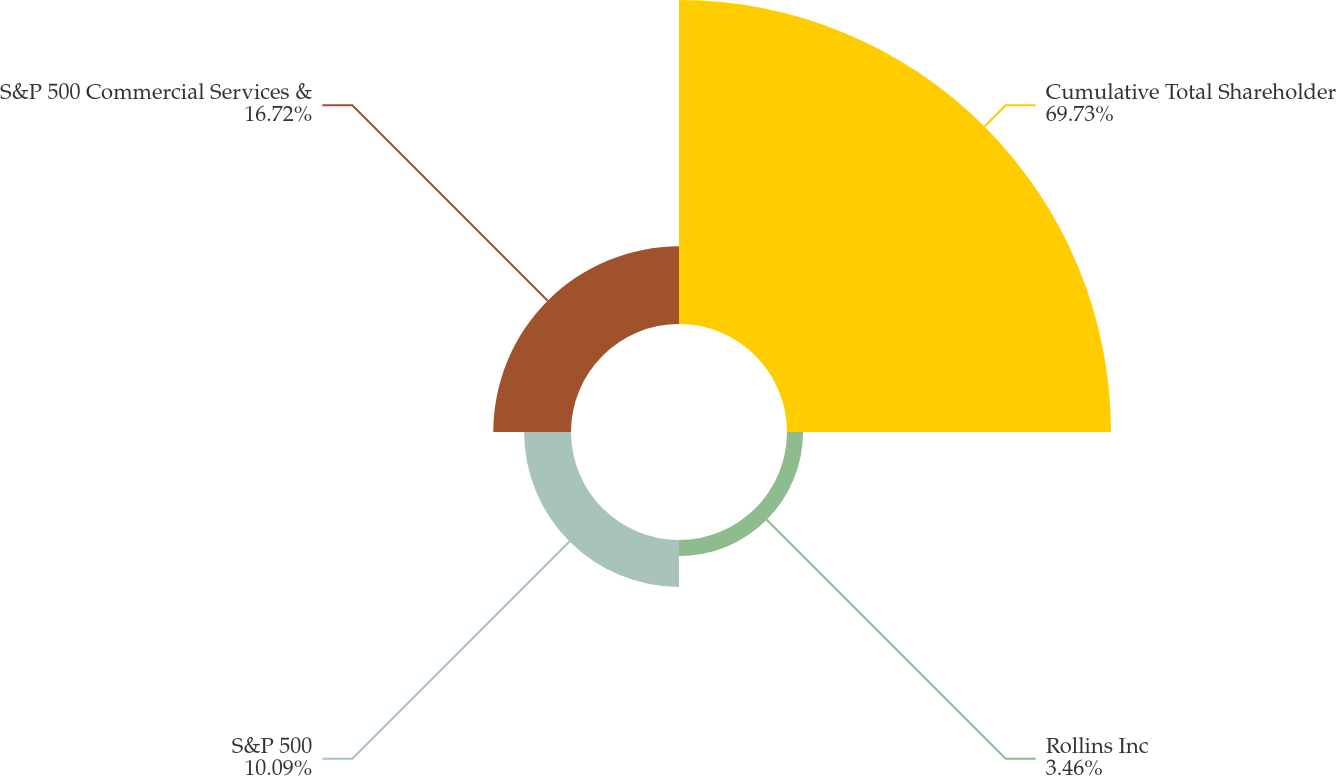Convert chart to OTSL. <chart><loc_0><loc_0><loc_500><loc_500><pie_chart><fcel>Cumulative Total Shareholder<fcel>Rollins Inc<fcel>S&P 500<fcel>S&P 500 Commercial Services &<nl><fcel>69.73%<fcel>3.46%<fcel>10.09%<fcel>16.72%<nl></chart> 